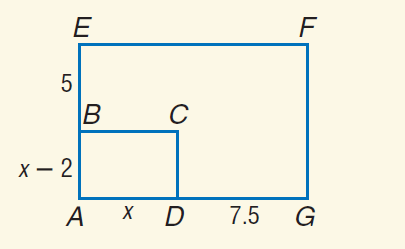Answer the mathemtical geometry problem and directly provide the correct option letter.
Question: The pair of polygons is similar. Find A B.
Choices: A: 3 B: 4 C: 5 D: 6 B 